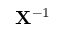<formula> <loc_0><loc_0><loc_500><loc_500>{ \mathbf X } ^ { - 1 }</formula> 